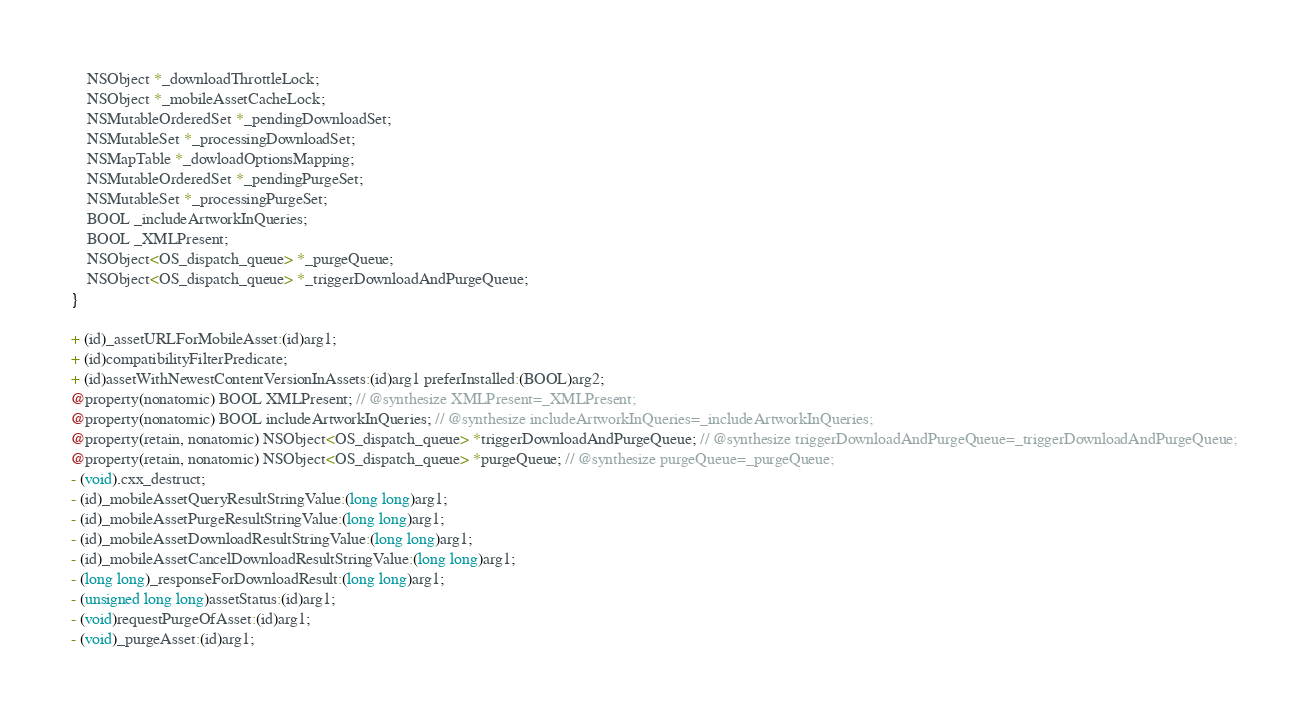<code> <loc_0><loc_0><loc_500><loc_500><_C_>    NSObject *_downloadThrottleLock;
    NSObject *_mobileAssetCacheLock;
    NSMutableOrderedSet *_pendingDownloadSet;
    NSMutableSet *_processingDownloadSet;
    NSMapTable *_dowloadOptionsMapping;
    NSMutableOrderedSet *_pendingPurgeSet;
    NSMutableSet *_processingPurgeSet;
    BOOL _includeArtworkInQueries;
    BOOL _XMLPresent;
    NSObject<OS_dispatch_queue> *_purgeQueue;
    NSObject<OS_dispatch_queue> *_triggerDownloadAndPurgeQueue;
}

+ (id)_assetURLForMobileAsset:(id)arg1;
+ (id)compatibilityFilterPredicate;
+ (id)assetWithNewestContentVersionInAssets:(id)arg1 preferInstalled:(BOOL)arg2;
@property(nonatomic) BOOL XMLPresent; // @synthesize XMLPresent=_XMLPresent;
@property(nonatomic) BOOL includeArtworkInQueries; // @synthesize includeArtworkInQueries=_includeArtworkInQueries;
@property(retain, nonatomic) NSObject<OS_dispatch_queue> *triggerDownloadAndPurgeQueue; // @synthesize triggerDownloadAndPurgeQueue=_triggerDownloadAndPurgeQueue;
@property(retain, nonatomic) NSObject<OS_dispatch_queue> *purgeQueue; // @synthesize purgeQueue=_purgeQueue;
- (void).cxx_destruct;
- (id)_mobileAssetQueryResultStringValue:(long long)arg1;
- (id)_mobileAssetPurgeResultStringValue:(long long)arg1;
- (id)_mobileAssetDownloadResultStringValue:(long long)arg1;
- (id)_mobileAssetCancelDownloadResultStringValue:(long long)arg1;
- (long long)_responseForDownloadResult:(long long)arg1;
- (unsigned long long)assetStatus:(id)arg1;
- (void)requestPurgeOfAsset:(id)arg1;
- (void)_purgeAsset:(id)arg1;</code> 